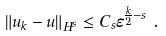Convert formula to latex. <formula><loc_0><loc_0><loc_500><loc_500>\left \| u _ { k } - u \right \| _ { H ^ { s } } & \leq C _ { s } \varepsilon ^ { \frac { k } { 2 } - s } \ .</formula> 